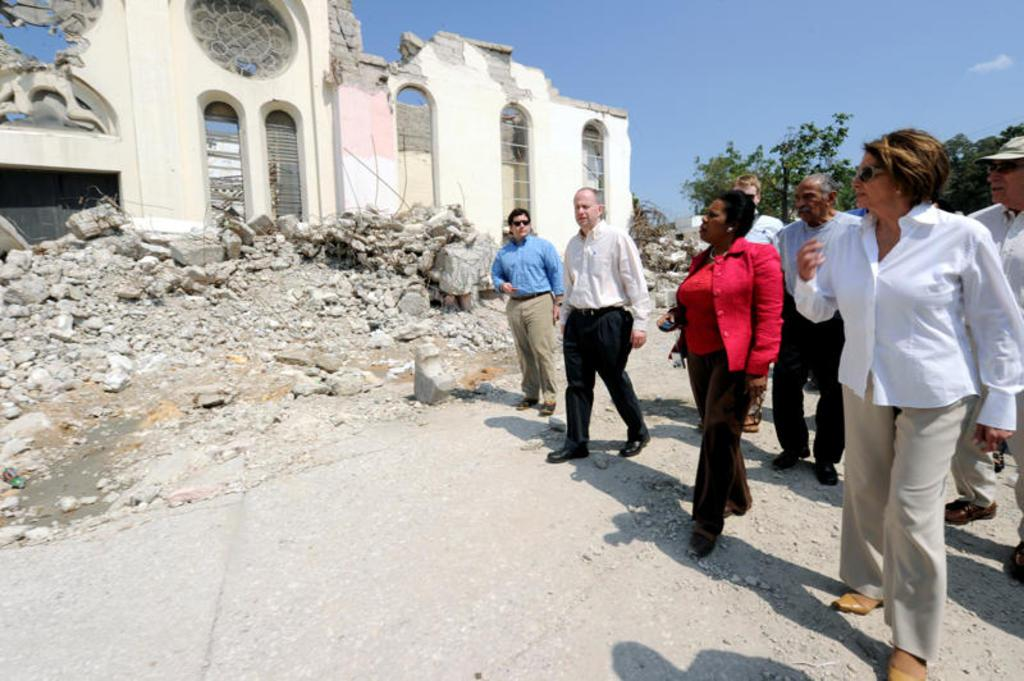What are the people in the image doing? The people in the image are walking on a path. What can be seen in the background of the image? There is a collapsed building visible in the image. What type of natural elements are present in the image? There are trees present in the image. What type of cork can be seen in the image? There is no cork present in the image. What is the reason for the building's collapse in the image? The provided facts do not give any information about the reason for the building's collapse. 